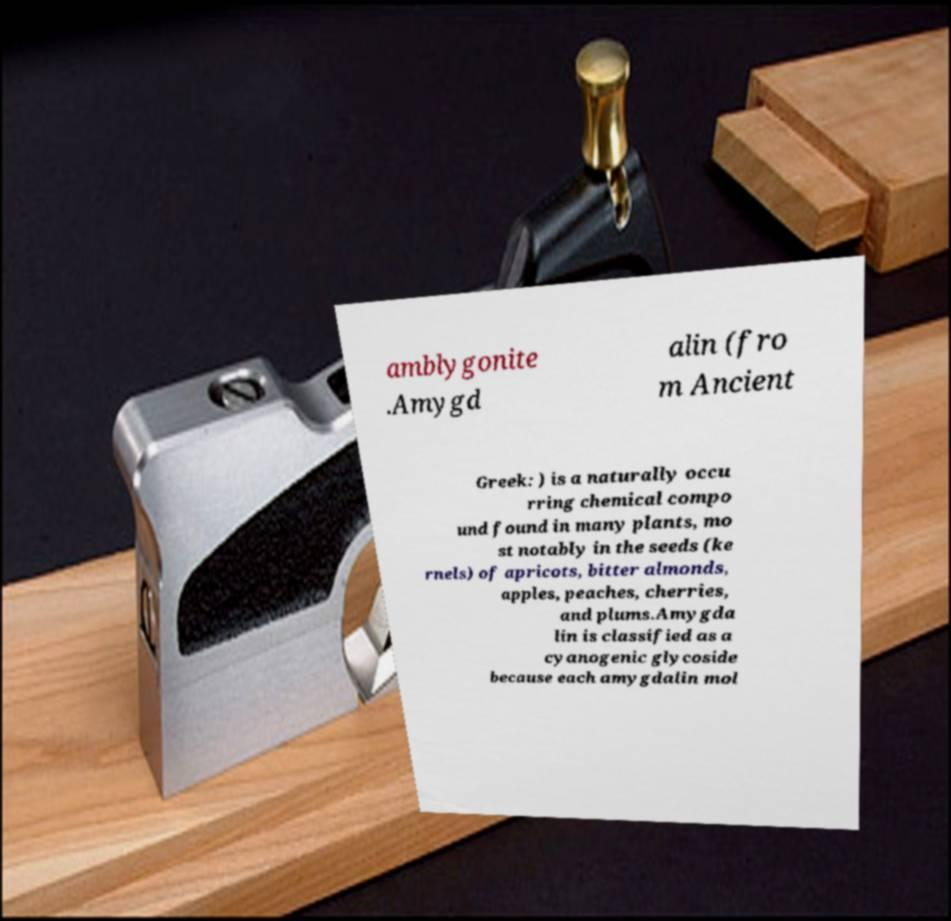Can you read and provide the text displayed in the image?This photo seems to have some interesting text. Can you extract and type it out for me? amblygonite .Amygd alin (fro m Ancient Greek: ) is a naturally occu rring chemical compo und found in many plants, mo st notably in the seeds (ke rnels) of apricots, bitter almonds, apples, peaches, cherries, and plums.Amygda lin is classified as a cyanogenic glycoside because each amygdalin mol 